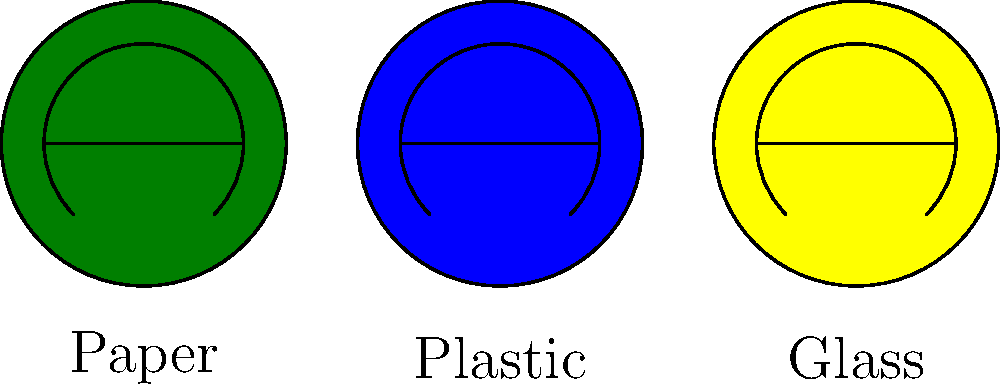At a local community event, you're tasked with improving the recycling system. The image shows three recycling bins for different materials. If you collect $x$ kg of paper, $2x$ kg of plastic, and $\frac{x}{2}$ kg of glass, what is the total weight of recyclables collected, expressed in terms of $x$? Let's break this down step-by-step:

1. Identify the weights for each material:
   - Paper: $x$ kg
   - Plastic: $2x$ kg
   - Glass: $\frac{x}{2}$ kg

2. To find the total weight, we need to add these together:
   Total weight = Weight of Paper + Weight of Plastic + Weight of Glass

3. Substitute the values:
   Total weight = $x + 2x + \frac{x}{2}$

4. Now, let's simplify this expression:
   $x + 2x + \frac{x}{2}$ = $3x + \frac{x}{2}$

5. To combine these terms, we need a common denominator. The common denominator is 2:
   $3x + \frac{x}{2}$ = $\frac{6x}{2} + \frac{x}{2}$ = $\frac{7x}{2}$

Therefore, the total weight of recyclables collected is $\frac{7x}{2}$ kg.
Answer: $\frac{7x}{2}$ kg 